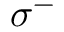<formula> <loc_0><loc_0><loc_500><loc_500>\sigma ^ { - }</formula> 